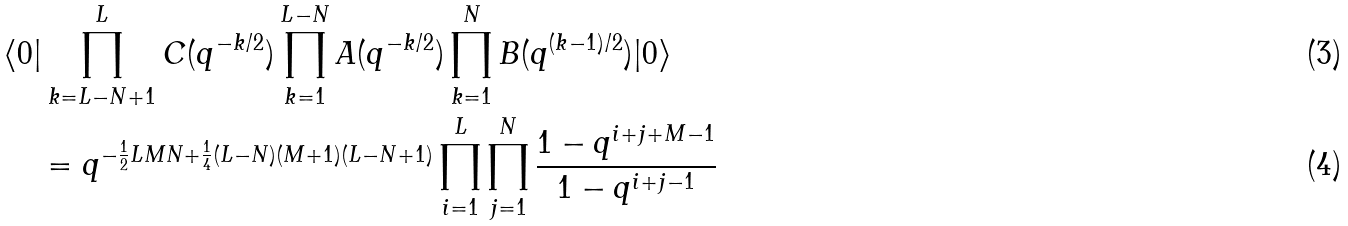Convert formula to latex. <formula><loc_0><loc_0><loc_500><loc_500>& \langle 0 | \prod _ { k = L - N + 1 } ^ { L } C ( q ^ { - k / 2 } ) \prod _ { k = 1 } ^ { L - N } A ( q ^ { - k / 2 } ) \prod _ { k = 1 } ^ { N } B ( q ^ { ( k - 1 ) / 2 } ) | 0 \rangle \\ & \quad = q ^ { { - \frac { 1 } { 2 } L M N + \frac { 1 } { 4 } ( L - N ) ( M + 1 ) ( L - N + 1 ) } } \prod _ { i = 1 } ^ { L } \prod _ { j = 1 } ^ { N } \frac { 1 - q ^ { i + j + M - 1 } } { 1 - q ^ { i + j - 1 } }</formula> 